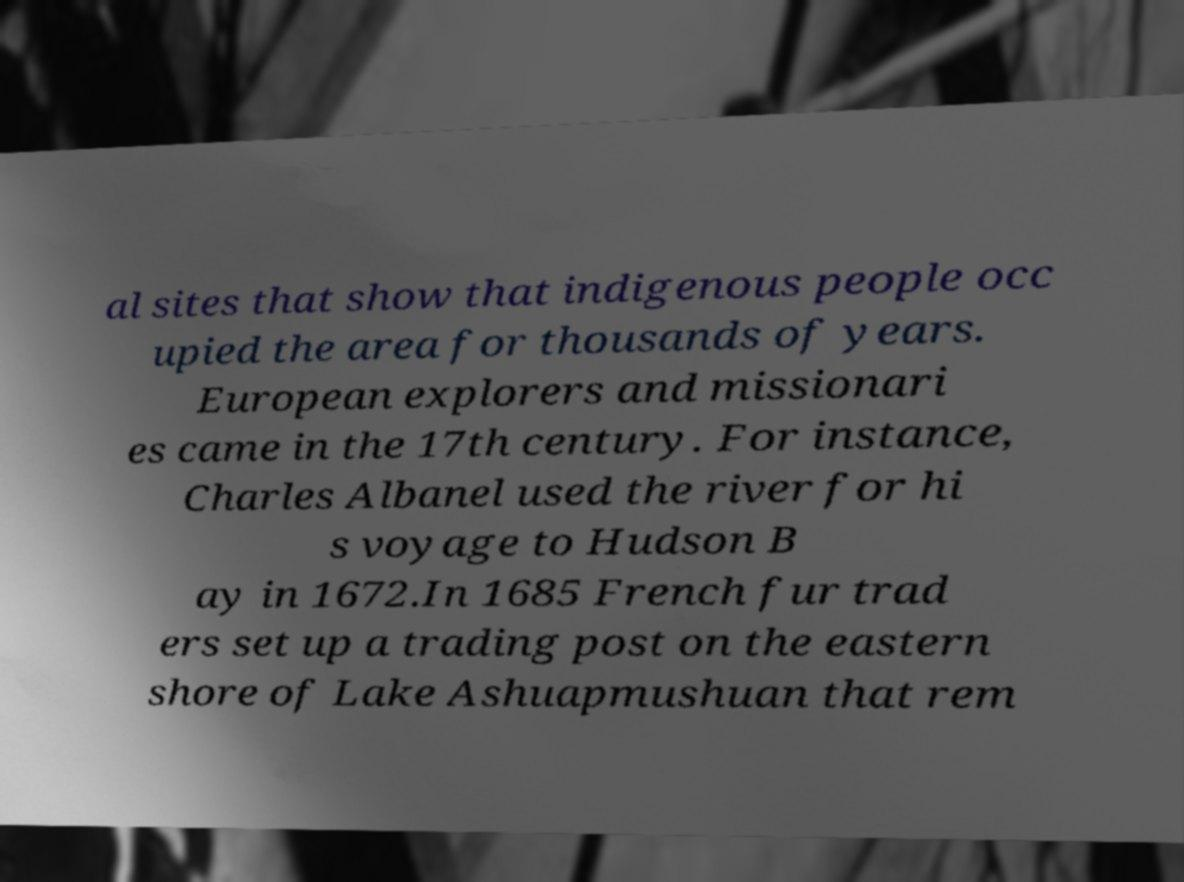For documentation purposes, I need the text within this image transcribed. Could you provide that? al sites that show that indigenous people occ upied the area for thousands of years. European explorers and missionari es came in the 17th century. For instance, Charles Albanel used the river for hi s voyage to Hudson B ay in 1672.In 1685 French fur trad ers set up a trading post on the eastern shore of Lake Ashuapmushuan that rem 